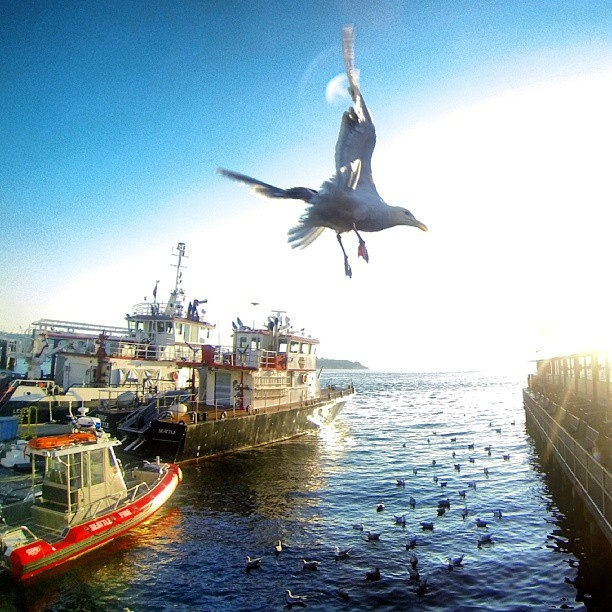Describe the objects in this image and their specific colors. I can see boat in blue, black, ivory, gray, and darkgray tones, boat in blue, gray, darkgray, black, and ivory tones, boat in blue, black, olive, tan, and khaki tones, boat in blue, gray, black, and tan tones, and bird in blue, gray, and darkgray tones in this image. 